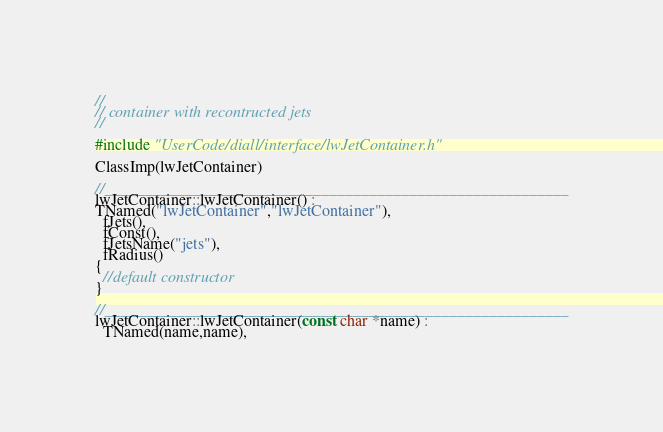<code> <loc_0><loc_0><loc_500><loc_500><_C++_>//
// container with recontructed jets
//

#include "UserCode/diall/interface/lwJetContainer.h"

ClassImp(lwJetContainer)

//__________________________________________________________
lwJetContainer::lwJetContainer() :
TNamed("lwJetContainer","lwJetContainer"),
  fJets(),
  fConst(),
  fJetsName("jets"),
  fRadius()
{
  //default constructor
}

//__________________________________________________________
lwJetContainer::lwJetContainer(const char *name) :
  TNamed(name,name),</code> 